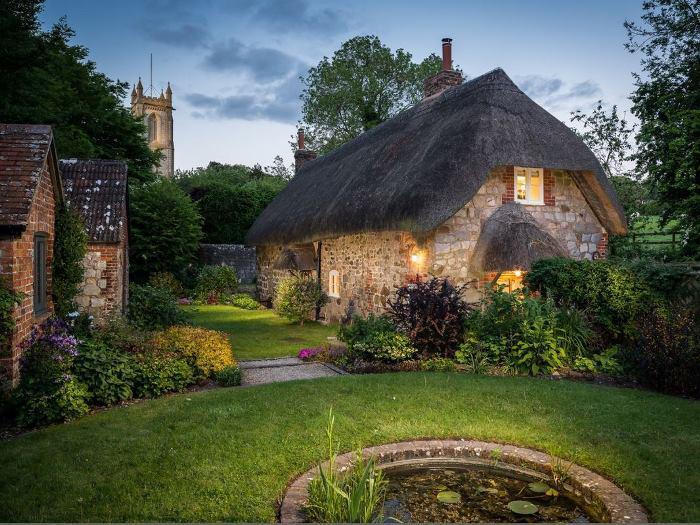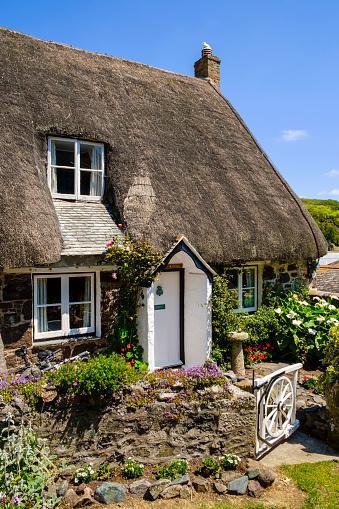The first image is the image on the left, the second image is the image on the right. For the images displayed, is the sentence "In at least one image there is a white house with black strip trim." factually correct? Answer yes or no. No. 